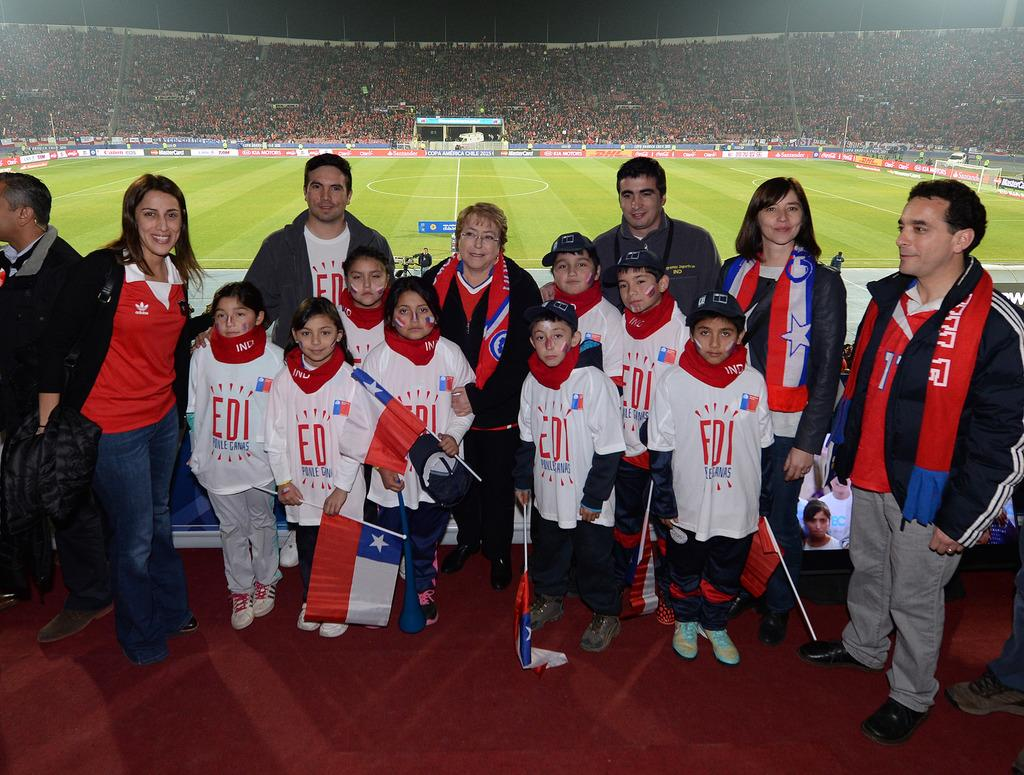<image>
Share a concise interpretation of the image provided. A group of kids and their parents at a soccer game wearing a shirt that says EDI on it. 